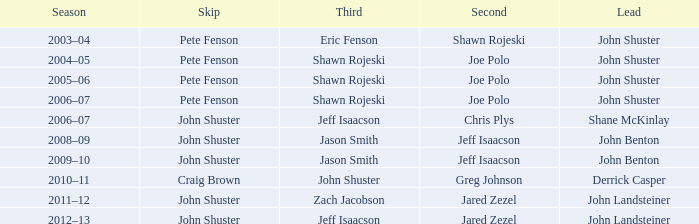Who was second when Shane McKinlay was the lead? Chris Plys. 